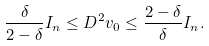<formula> <loc_0><loc_0><loc_500><loc_500>\frac { \delta } { 2 - \delta } I _ { n } \leq D ^ { 2 } v _ { 0 } \leq \frac { 2 - \delta } { \delta } I _ { n } .</formula> 